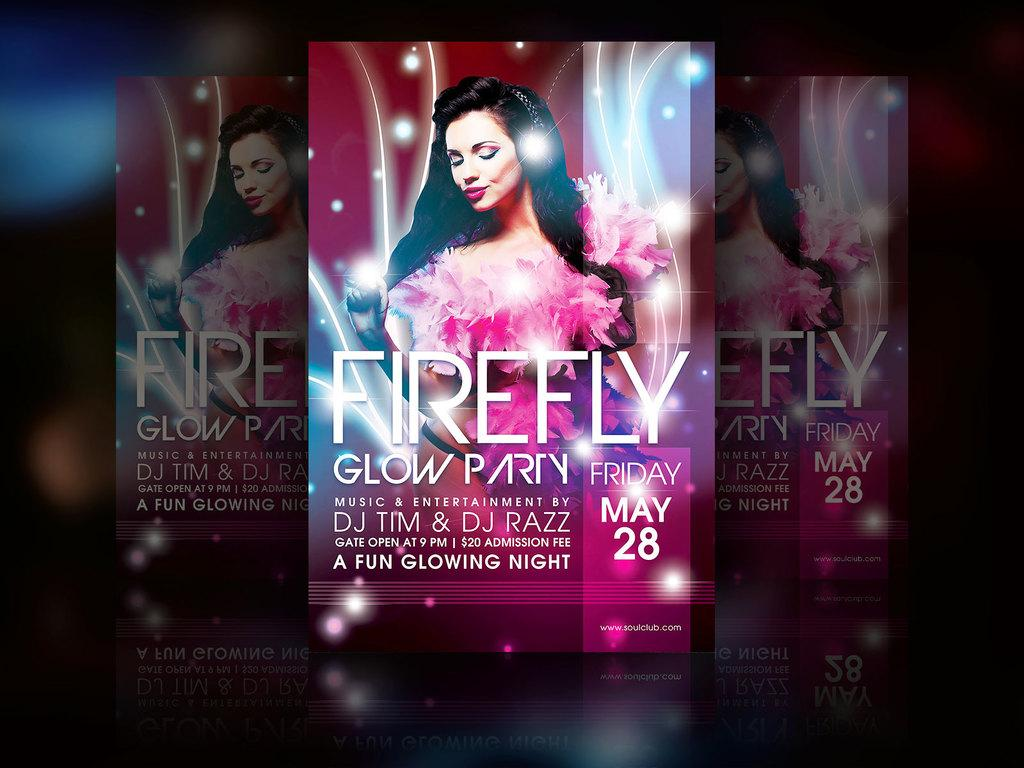Provide a one-sentence caption for the provided image. Posters with firefly glow party wrote on the front of it. 